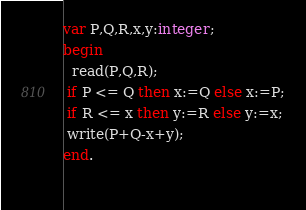<code> <loc_0><loc_0><loc_500><loc_500><_Pascal_>var P,Q,R,x,y:integer;
begin
  read(P,Q,R);
 if P <= Q then x:=Q else x:=P;
 if R <= x then y:=R else y:=x;
 write(P+Q-x+y);
end.
 </code> 